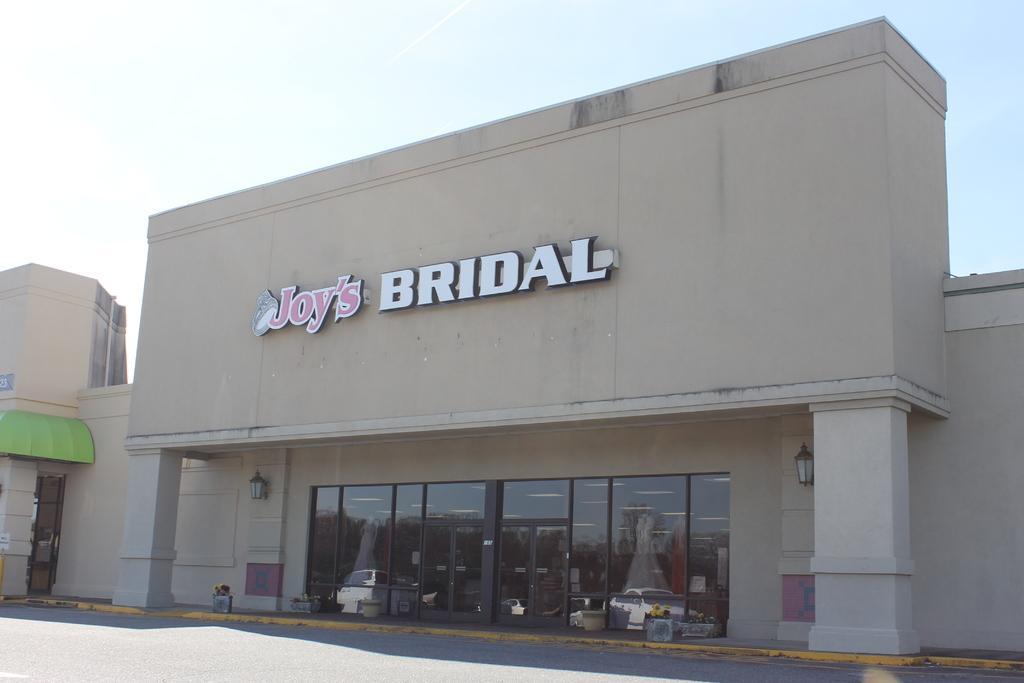How would you summarize this image in a sentence or two? In this image we can see a building and there is a text on the building. At the top there is sky and at the bottom there is road. 